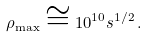Convert formula to latex. <formula><loc_0><loc_0><loc_500><loc_500>\rho _ { \max } \cong 1 0 ^ { 1 0 } s ^ { 1 / 2 } \, .</formula> 